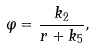Convert formula to latex. <formula><loc_0><loc_0><loc_500><loc_500>\varphi = { \frac { k _ { 2 } } { r + k _ { 5 } } } ,</formula> 